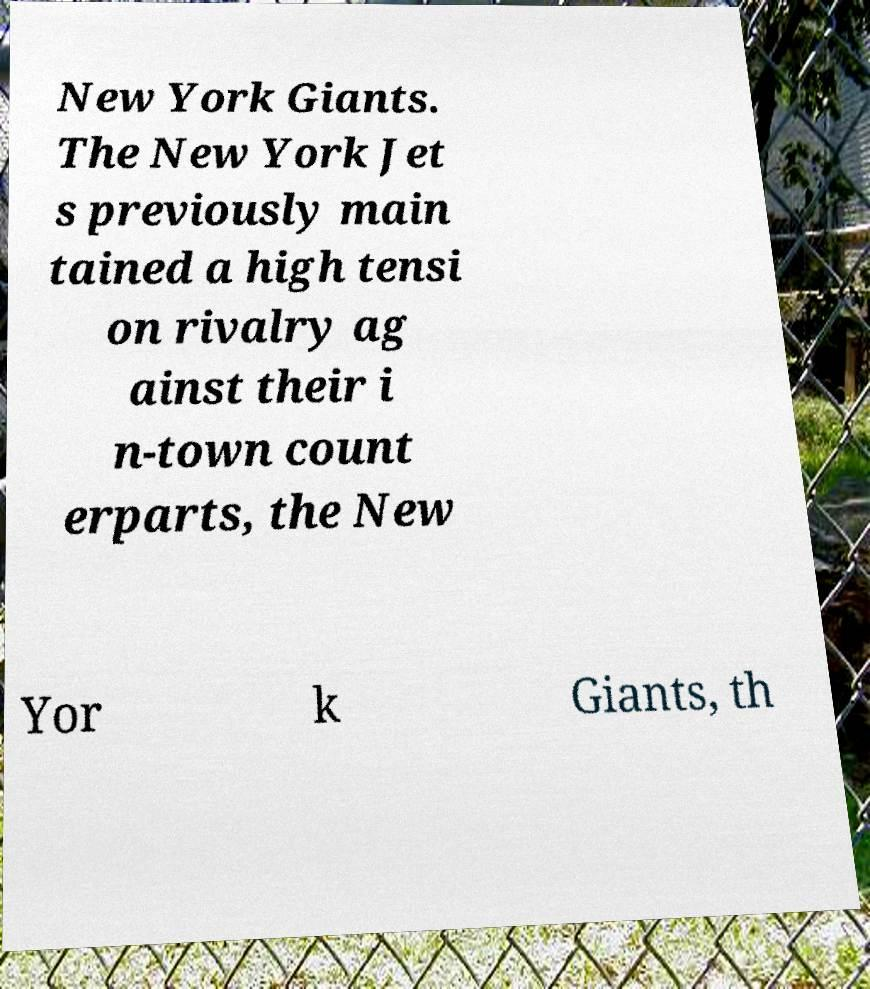Can you read and provide the text displayed in the image?This photo seems to have some interesting text. Can you extract and type it out for me? New York Giants. The New York Jet s previously main tained a high tensi on rivalry ag ainst their i n-town count erparts, the New Yor k Giants, th 